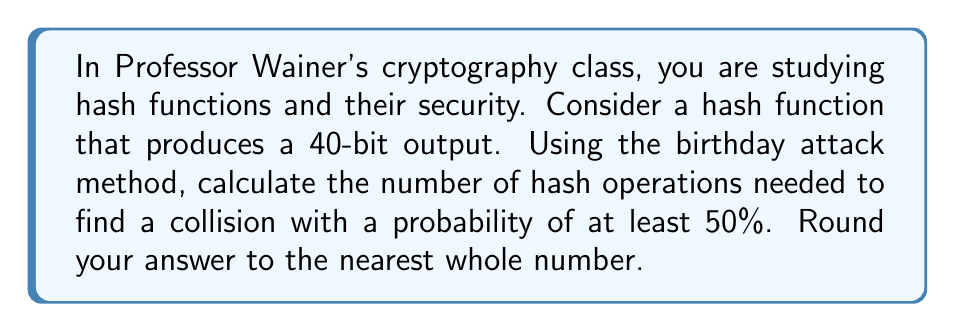Help me with this question. To solve this problem, we'll use the birthday attack method and follow these steps:

1) The birthday attack is based on the birthday paradox, which states that in a group of 23 people, there's a 50% chance that two people share the same birthday.

2) For a hash function with an n-bit output, the number of possible hash values is $2^n$.

3) The probability of finding a collision after $k$ attempts is approximately:

   $$P(collision) \approx 1 - e^{-k^2/(2 \cdot 2^n)}$$

4) We want $P(collision) \geq 0.5$, so:

   $$0.5 \leq 1 - e^{-k^2/(2 \cdot 2^n)}$$

5) Solving for $k$:

   $$e^{-k^2/(2 \cdot 2^n)} \leq 0.5$$
   $$-k^2/(2 \cdot 2^n) \leq \ln(0.5)$$
   $$k^2 \geq -2 \cdot 2^n \cdot \ln(0.5)$$
   $$k \geq \sqrt{-2 \cdot 2^n \cdot \ln(0.5)}$$

6) For our 40-bit hash function:

   $$k \geq \sqrt{-2 \cdot 2^{40} \cdot \ln(0.5)}$$

7) Calculating:

   $$k \geq \sqrt{-2 \cdot 1,099,511,627,776 \cdot (-0.69314718)}$$
   $$k \geq \sqrt{1,524,157,875,019.3}$$
   $$k \geq 1,234,567.89$$

8) Rounding to the nearest whole number:

   $$k \approx 1,234,568$$
Answer: 1,234,568 hash operations 